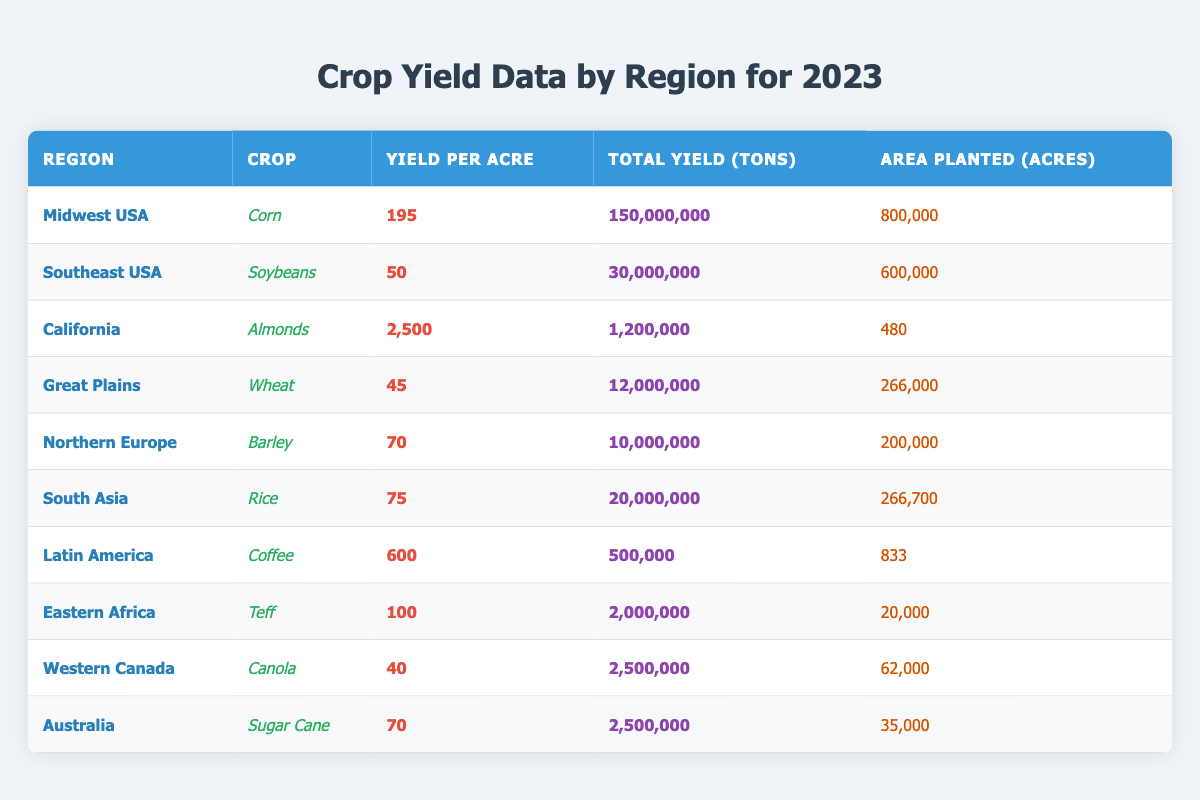What is the yield per acre for Corn in the Midwest USA? The yield per acre for Corn is listed in the table under the Midwest USA region, where the value is bolded. It shows 195.
Answer: 195 Which crop has the highest yield per acre? By reviewing the yield per acre values for all crops, we see that Almonds in California has the highest value of 2,500.
Answer: 2,500 How many total tons of Soybeans were produced in the Southeast USA? The total yield for Soybeans in the Southeast USA is presented in the table, which states 30,000,000 tons.
Answer: 30,000,000 What is the total planted area for Wheat in the Great Plains? The area planted for Wheat in the Great Plains is specified in the table, showing a value of 266,000 acres.
Answer: 266,000 Is the total yield for Rice in South Asia greater than 15 million tons? The total yield for Rice is 20,000,000 tons, which is indeed greater than 15 million tons. Therefore, the answer is true.
Answer: True What is the combined total yield in tons for Canola in Western Canada and Sugar Cane in Australia? The total yield of Canola is 2,500,000 tons, and for Sugar Cane, it's also 2,500,000 tons. Adding these gives 2,500,000 + 2,500,000 = 5,000,000 tons.
Answer: 5,000,000 Which region has the largest area planted, and what crop is grown there? By comparing the areas planted across all regions, Midwest USA has the largest area at 800,000 acres for the crop Corn.
Answer: Midwest USA, Corn If you were to calculate the average yield per acre for all crops listed, what would that be? To find the average yield per acre, we sum the yield per acre values: (195 + 50 + 2500 + 45 + 70 + 75 + 600 + 100 + 40 + 70) = 4,640. Then, we divide this by the number of crops (10), resulting in an average of 464.
Answer: 464 In Eastern Africa, what is the yield per acre and total yield for Teff? The yield per acre for Teff in Eastern Africa is 100, and the total yield is 2,000,000 tons, both of which are displayed in the respective columns of the table.
Answer: 100, 2,000,000 How does the yield per acre for Barley in Northern Europe compare to the yield per acre for Wheat in the Great Plains? The yield per acre for Barley is 70 while for Wheat it is 45. Since 70 is greater than 45, Barley has a higher yield per acre than Wheat.
Answer: Barley is higher 